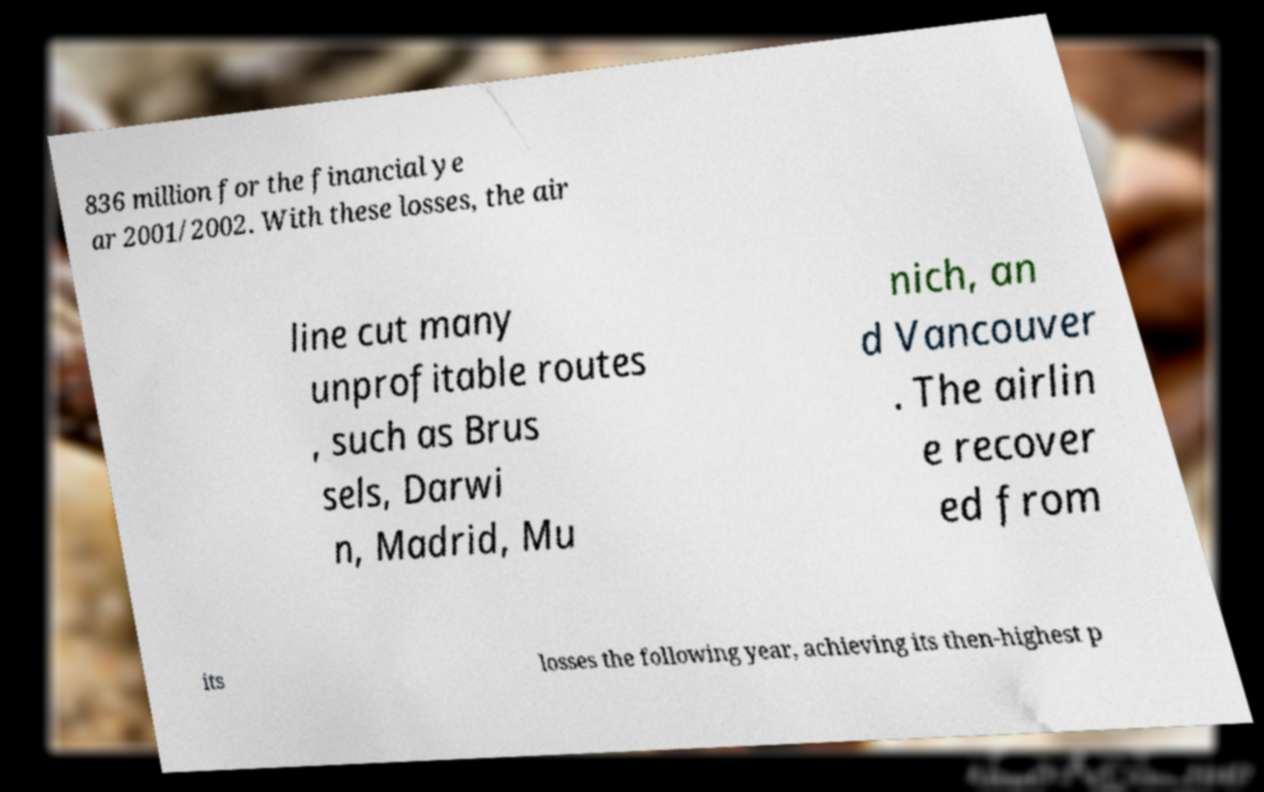What messages or text are displayed in this image? I need them in a readable, typed format. 836 million for the financial ye ar 2001/2002. With these losses, the air line cut many unprofitable routes , such as Brus sels, Darwi n, Madrid, Mu nich, an d Vancouver . The airlin e recover ed from its losses the following year, achieving its then-highest p 